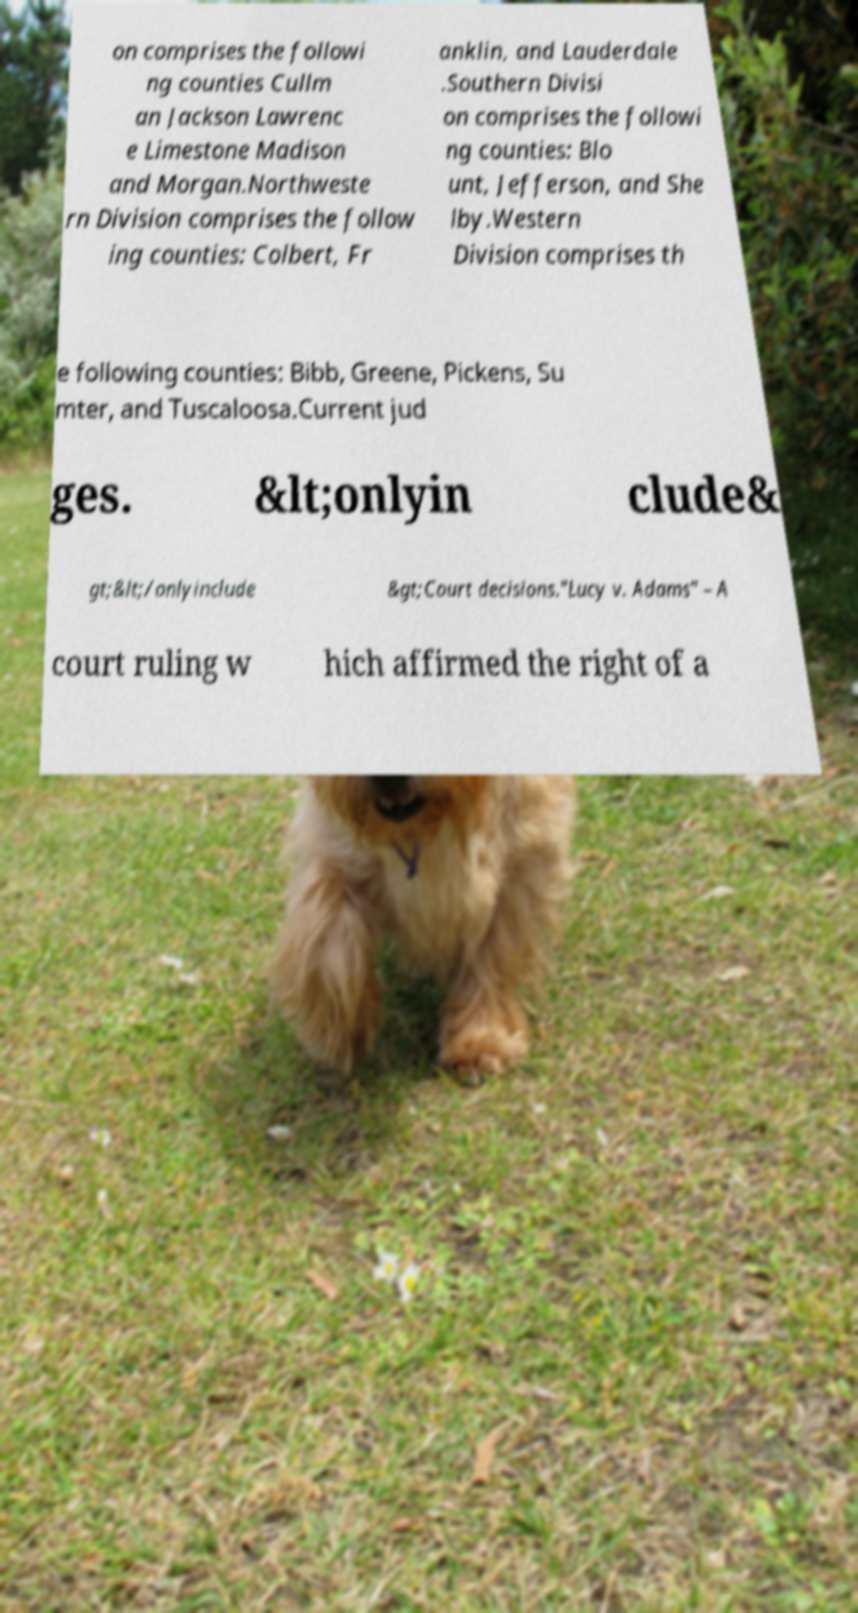What messages or text are displayed in this image? I need them in a readable, typed format. on comprises the followi ng counties Cullm an Jackson Lawrenc e Limestone Madison and Morgan.Northweste rn Division comprises the follow ing counties: Colbert, Fr anklin, and Lauderdale .Southern Divisi on comprises the followi ng counties: Blo unt, Jefferson, and She lby.Western Division comprises th e following counties: Bibb, Greene, Pickens, Su mter, and Tuscaloosa.Current jud ges. &lt;onlyin clude& gt;&lt;/onlyinclude &gt;Court decisions."Lucy v. Adams" – A court ruling w hich affirmed the right of a 